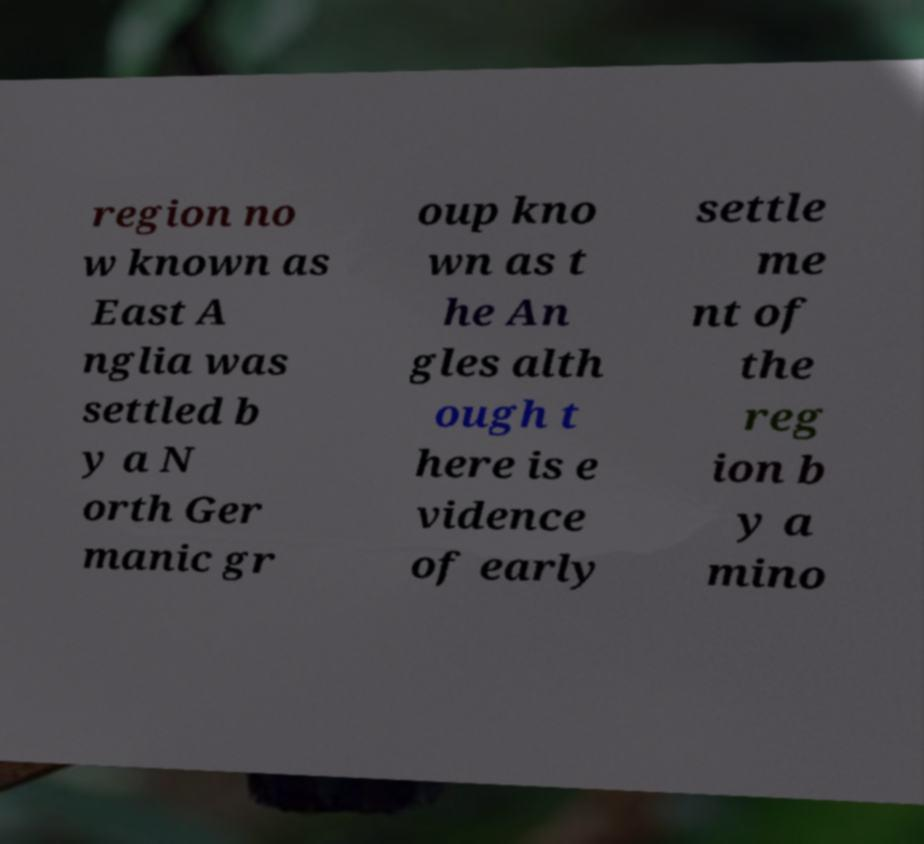Can you accurately transcribe the text from the provided image for me? region no w known as East A nglia was settled b y a N orth Ger manic gr oup kno wn as t he An gles alth ough t here is e vidence of early settle me nt of the reg ion b y a mino 